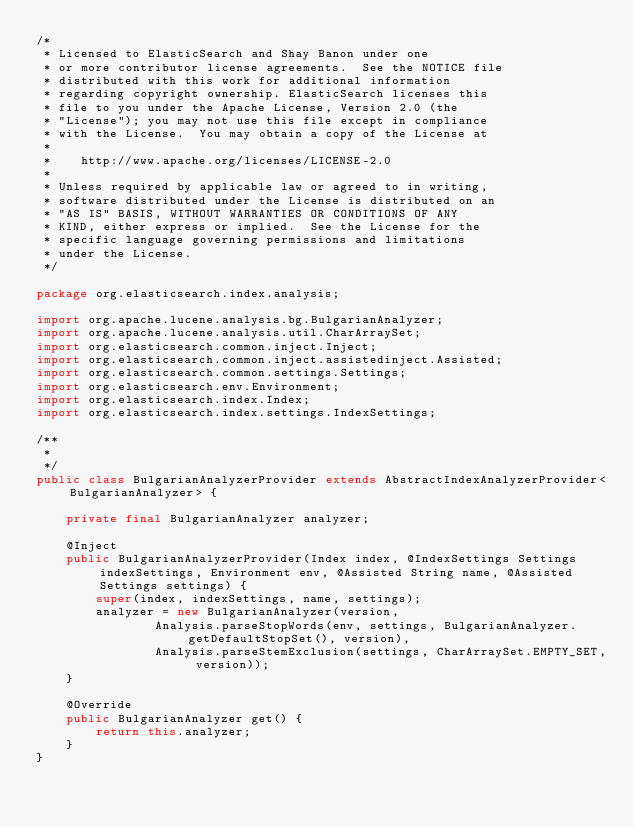<code> <loc_0><loc_0><loc_500><loc_500><_Java_>/*
 * Licensed to ElasticSearch and Shay Banon under one
 * or more contributor license agreements.  See the NOTICE file
 * distributed with this work for additional information
 * regarding copyright ownership. ElasticSearch licenses this
 * file to you under the Apache License, Version 2.0 (the
 * "License"); you may not use this file except in compliance
 * with the License.  You may obtain a copy of the License at
 *
 *    http://www.apache.org/licenses/LICENSE-2.0
 *
 * Unless required by applicable law or agreed to in writing,
 * software distributed under the License is distributed on an
 * "AS IS" BASIS, WITHOUT WARRANTIES OR CONDITIONS OF ANY
 * KIND, either express or implied.  See the License for the
 * specific language governing permissions and limitations
 * under the License.
 */

package org.elasticsearch.index.analysis;

import org.apache.lucene.analysis.bg.BulgarianAnalyzer;
import org.apache.lucene.analysis.util.CharArraySet;
import org.elasticsearch.common.inject.Inject;
import org.elasticsearch.common.inject.assistedinject.Assisted;
import org.elasticsearch.common.settings.Settings;
import org.elasticsearch.env.Environment;
import org.elasticsearch.index.Index;
import org.elasticsearch.index.settings.IndexSettings;

/**
 *
 */
public class BulgarianAnalyzerProvider extends AbstractIndexAnalyzerProvider<BulgarianAnalyzer> {

    private final BulgarianAnalyzer analyzer;

    @Inject
    public BulgarianAnalyzerProvider(Index index, @IndexSettings Settings indexSettings, Environment env, @Assisted String name, @Assisted Settings settings) {
        super(index, indexSettings, name, settings);
        analyzer = new BulgarianAnalyzer(version,
                Analysis.parseStopWords(env, settings, BulgarianAnalyzer.getDefaultStopSet(), version),
                Analysis.parseStemExclusion(settings, CharArraySet.EMPTY_SET, version));
    }

    @Override
    public BulgarianAnalyzer get() {
        return this.analyzer;
    }
}</code> 